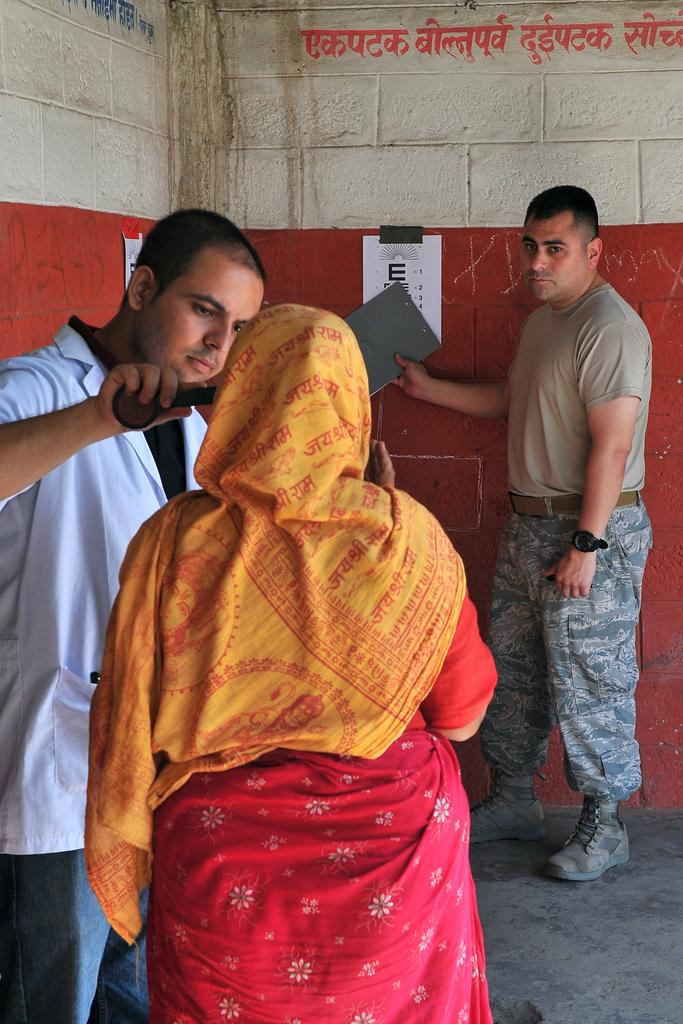How many people are present in the image? There are three persons in the image. Can you describe the gender of the people in the image? There are two men and one woman in the image. What is the woman wearing in the image? The woman is wearing a saree. What can be seen in the background of the image? There is a wall in the background of the image. What is attached to the wall in the image? There are two papers pasted on the wall. What type of creature can be seen singing a song in the image? There is no creature or singing in the image; it features three people, including two men and a woman wearing a saree. What type of vessel is being used by the woman in the image? There is no vessel present in the image; the woman is wearing a saree and standing near two men. 